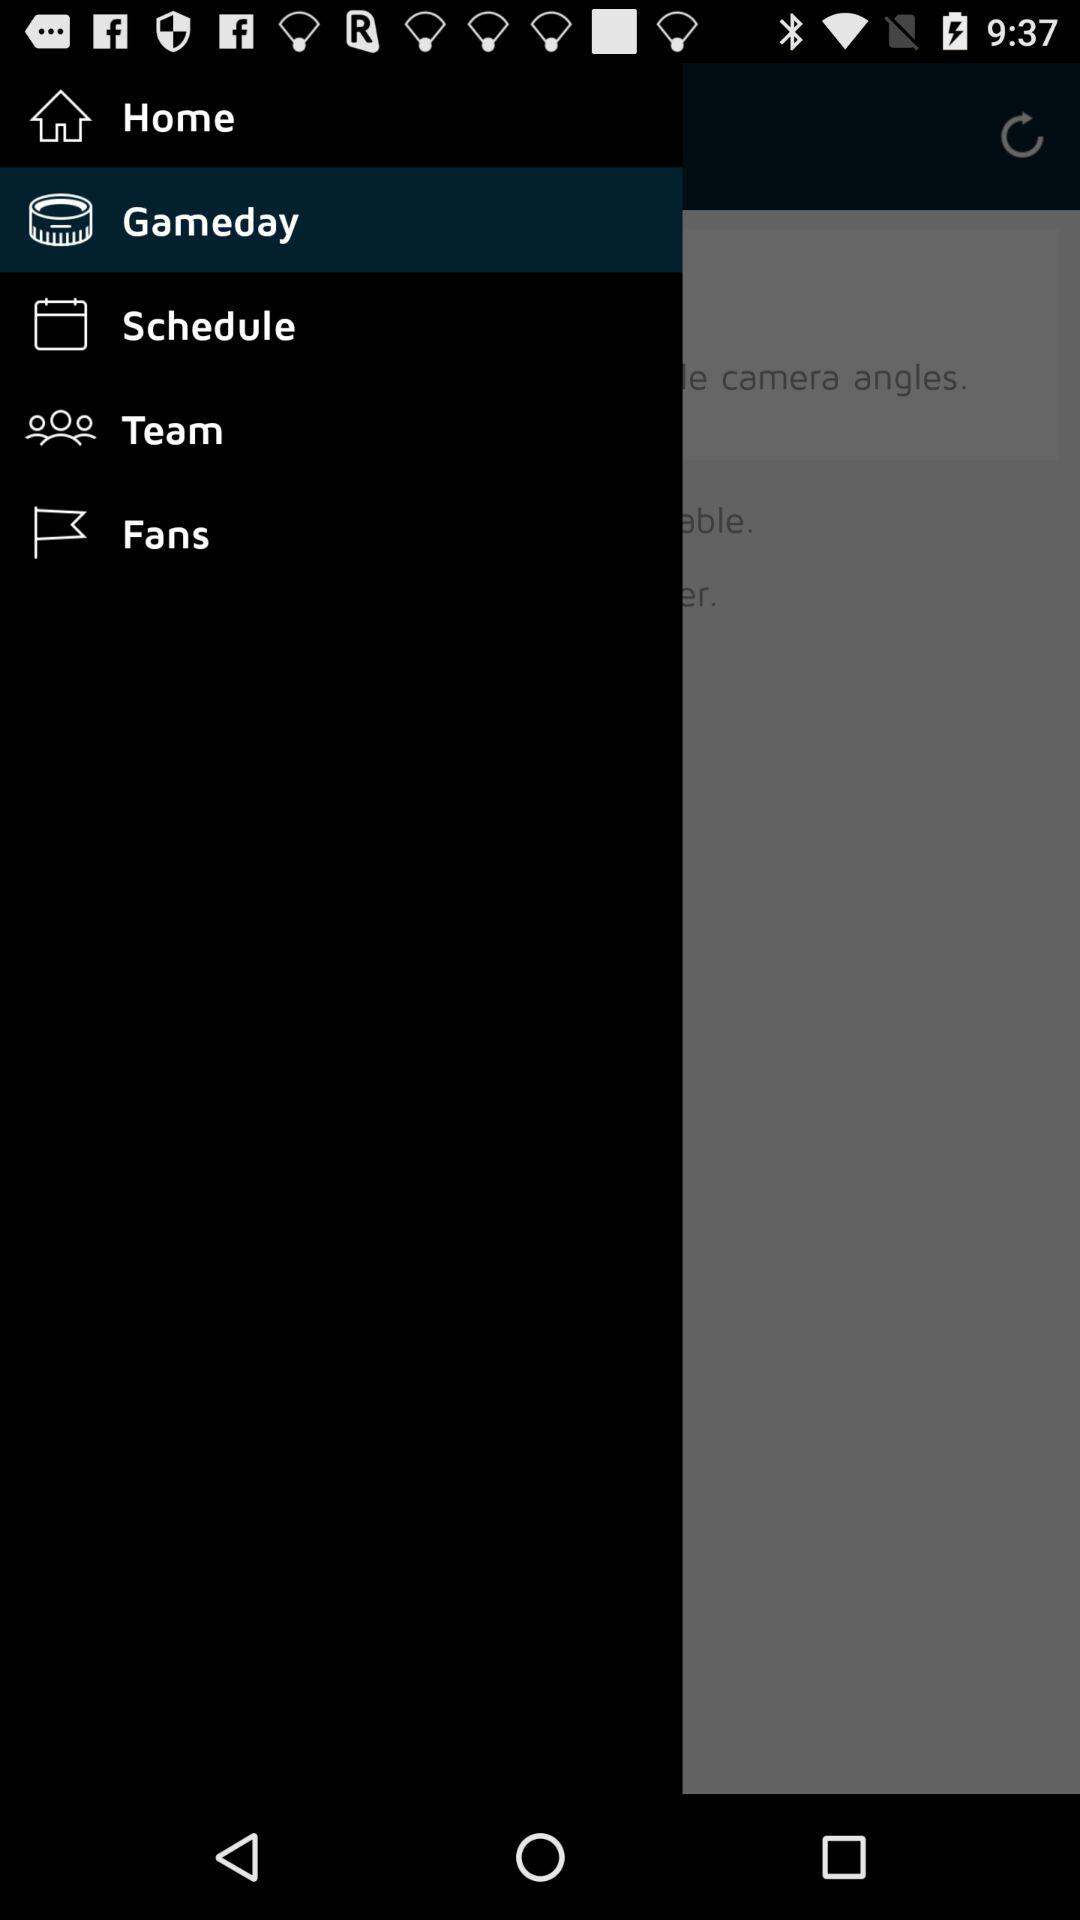Which option is selected? The selected option is "Gameday". 